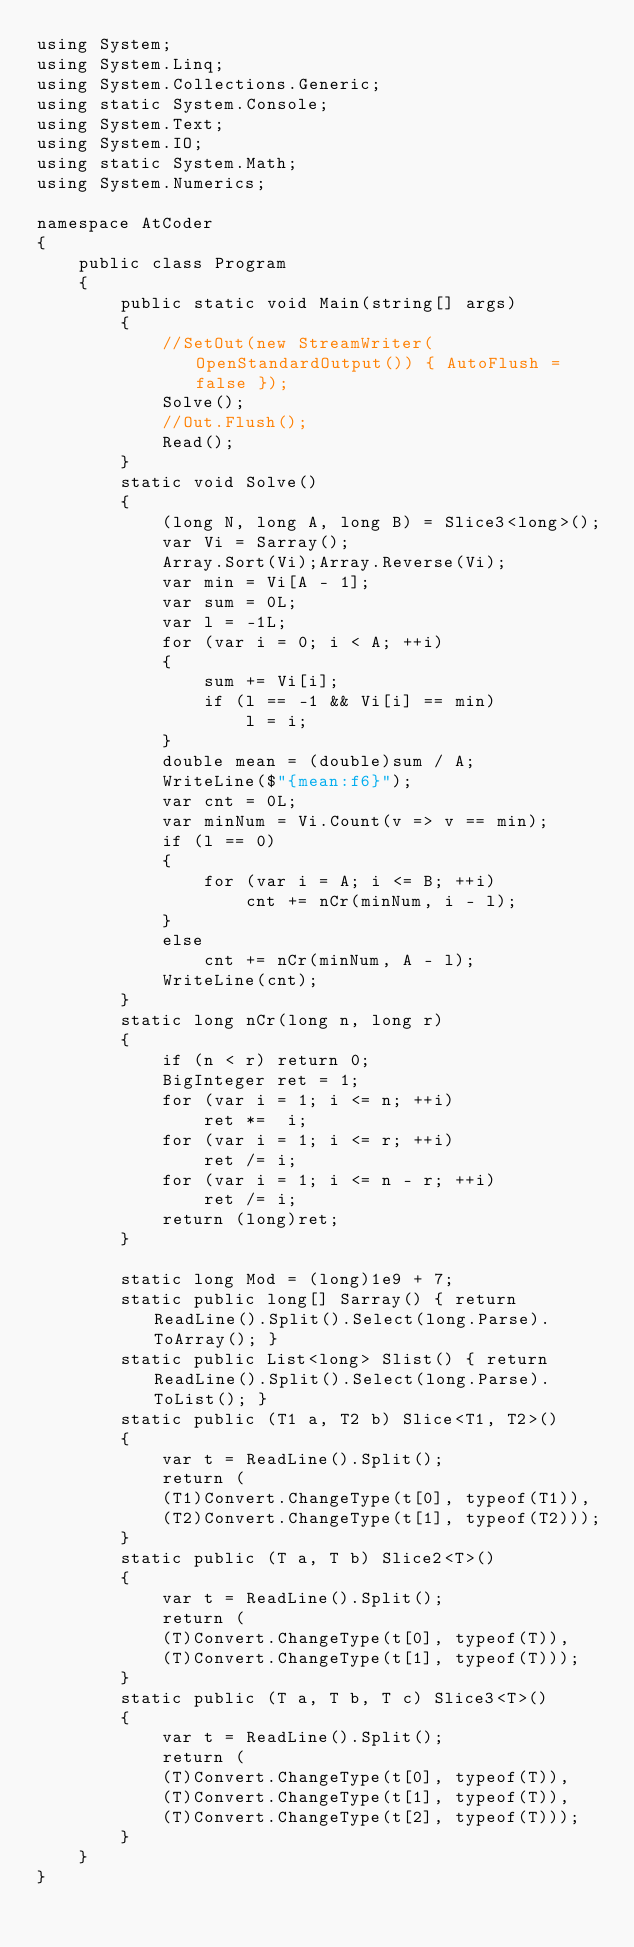<code> <loc_0><loc_0><loc_500><loc_500><_C#_>using System;
using System.Linq;
using System.Collections.Generic;
using static System.Console;
using System.Text;
using System.IO;
using static System.Math;
using System.Numerics;

namespace AtCoder
{
    public class Program
    {
        public static void Main(string[] args)
        {
            //SetOut(new StreamWriter(OpenStandardOutput()) { AutoFlush = false });
            Solve();
            //Out.Flush();
            Read();
        }
        static void Solve()
        {
            (long N, long A, long B) = Slice3<long>();
            var Vi = Sarray();
            Array.Sort(Vi);Array.Reverse(Vi);
            var min = Vi[A - 1];
            var sum = 0L;
            var l = -1L;
            for (var i = 0; i < A; ++i)
            {
                sum += Vi[i];
                if (l == -1 && Vi[i] == min)
                    l = i;
            }
            double mean = (double)sum / A;
            WriteLine($"{mean:f6}");
            var cnt = 0L;
            var minNum = Vi.Count(v => v == min);
            if (l == 0)
            {
                for (var i = A; i <= B; ++i)
                    cnt += nCr(minNum, i - l);
            }
            else
                cnt += nCr(minNum, A - l);
            WriteLine(cnt);
        }
        static long nCr(long n, long r)
        {
            if (n < r) return 0;
            BigInteger ret = 1;
            for (var i = 1; i <= n; ++i)
                ret *=  i;
            for (var i = 1; i <= r; ++i)
                ret /= i;
            for (var i = 1; i <= n - r; ++i)
                ret /= i;
            return (long)ret;
        }

        static long Mod = (long)1e9 + 7;
        static public long[] Sarray() { return ReadLine().Split().Select(long.Parse).ToArray(); }
        static public List<long> Slist() { return ReadLine().Split().Select(long.Parse).ToList(); }
        static public (T1 a, T2 b) Slice<T1, T2>()
        {
            var t = ReadLine().Split();
            return (
            (T1)Convert.ChangeType(t[0], typeof(T1)),
            (T2)Convert.ChangeType(t[1], typeof(T2)));
        }
        static public (T a, T b) Slice2<T>()
        {
            var t = ReadLine().Split();
            return (
            (T)Convert.ChangeType(t[0], typeof(T)),
            (T)Convert.ChangeType(t[1], typeof(T)));
        }
        static public (T a, T b, T c) Slice3<T>()
        {
            var t = ReadLine().Split();
            return (
            (T)Convert.ChangeType(t[0], typeof(T)),
            (T)Convert.ChangeType(t[1], typeof(T)),
            (T)Convert.ChangeType(t[2], typeof(T)));
        }
    }
}</code> 